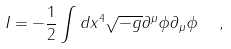Convert formula to latex. <formula><loc_0><loc_0><loc_500><loc_500>I = - \frac { 1 } { 2 } \int d x ^ { 4 } \sqrt { - g } \partial ^ { \mu } \phi \partial _ { \mu } \phi \ \ ,</formula> 